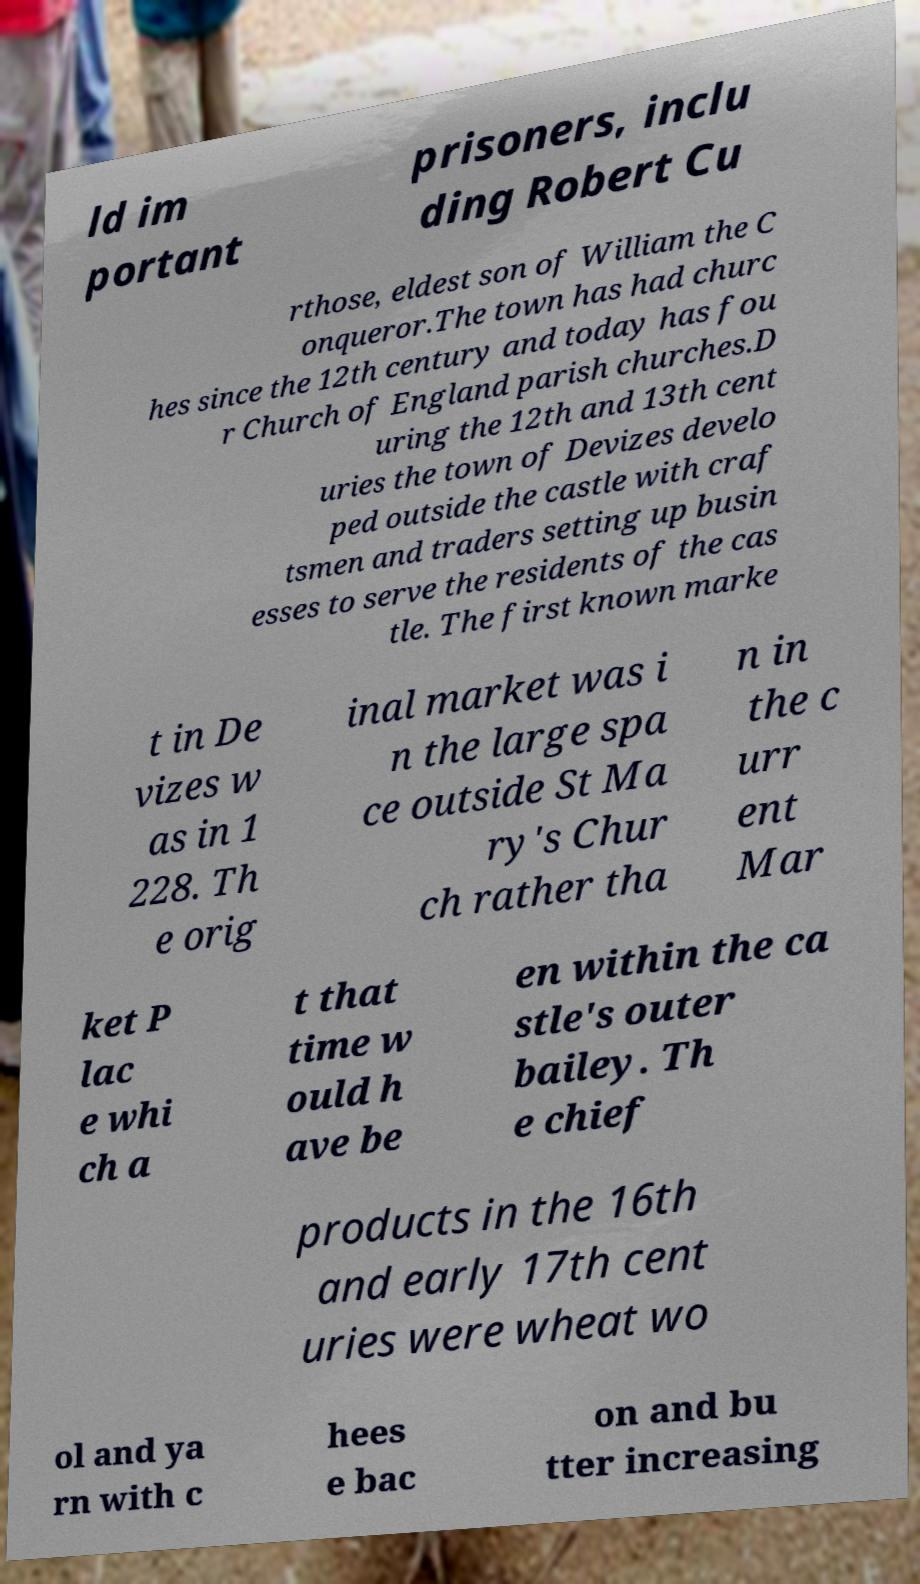Can you read and provide the text displayed in the image?This photo seems to have some interesting text. Can you extract and type it out for me? ld im portant prisoners, inclu ding Robert Cu rthose, eldest son of William the C onqueror.The town has had churc hes since the 12th century and today has fou r Church of England parish churches.D uring the 12th and 13th cent uries the town of Devizes develo ped outside the castle with craf tsmen and traders setting up busin esses to serve the residents of the cas tle. The first known marke t in De vizes w as in 1 228. Th e orig inal market was i n the large spa ce outside St Ma ry's Chur ch rather tha n in the c urr ent Mar ket P lac e whi ch a t that time w ould h ave be en within the ca stle's outer bailey. Th e chief products in the 16th and early 17th cent uries were wheat wo ol and ya rn with c hees e bac on and bu tter increasing 